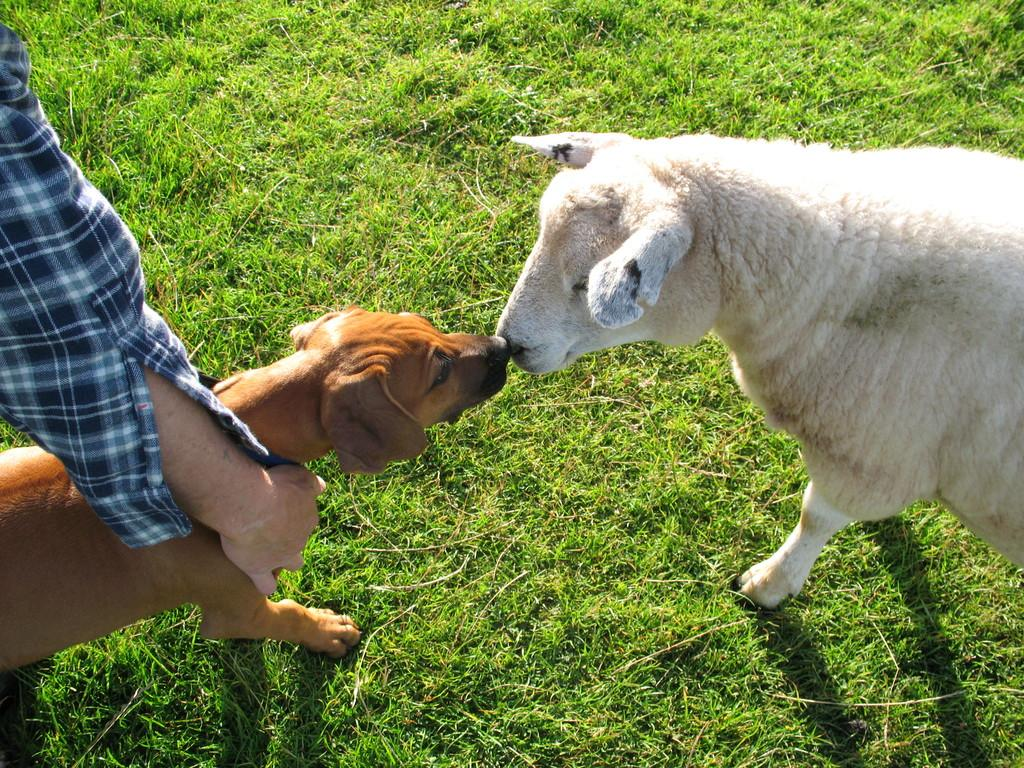What type of animal can be seen in the image? There is a dog in the image. What other animals are present in the image? There are sheep in the image. What is the surface that the dog and sheep are standing on? The dog and sheep are on the grass. Can you describe the person's hand visible in the image? The person's hand is visible in the image, and they are wearing a checked shirt. What time does the ghost appear in the image? There is no ghost present in the image. How does the thunder affect the dog and sheep in the image? There is no thunder present in the image. 